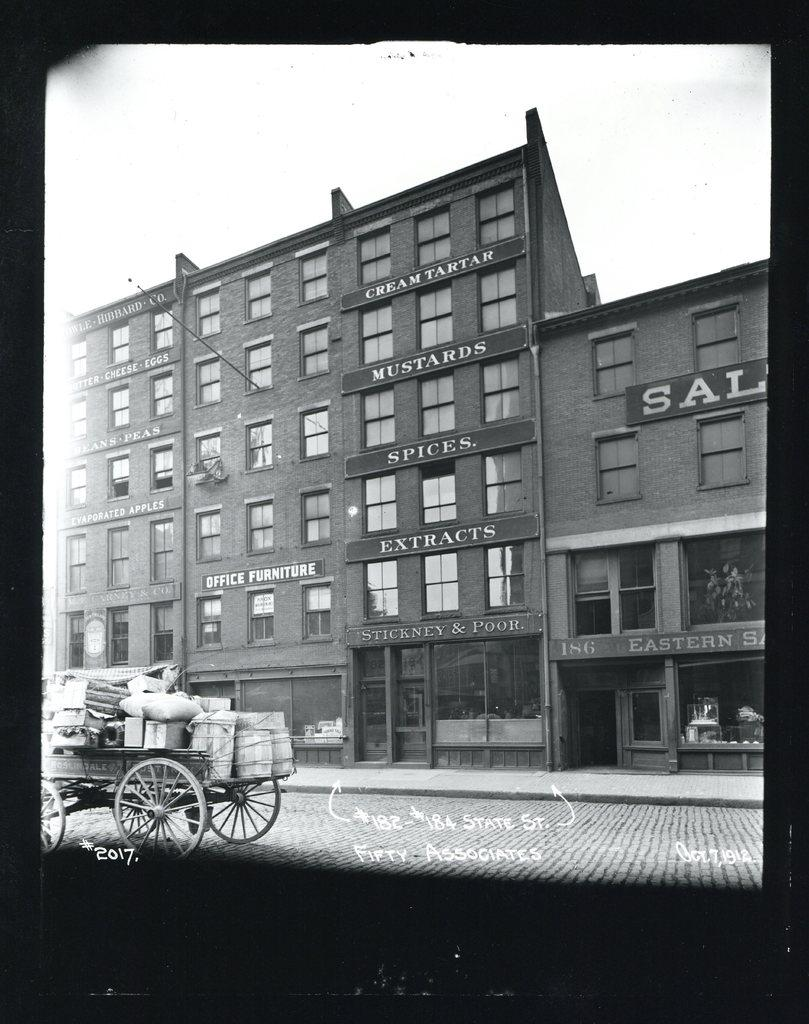What type of image is this? The image appears to be a photograph. What can be seen in the image? There is a road, a cart with luggage on the left side, and buildings in the image. What achievement did the brother accomplish in the image? There is no mention of a brother or any achievements in the image. What type of truck can be seen in the image? There is no truck present in the image. 